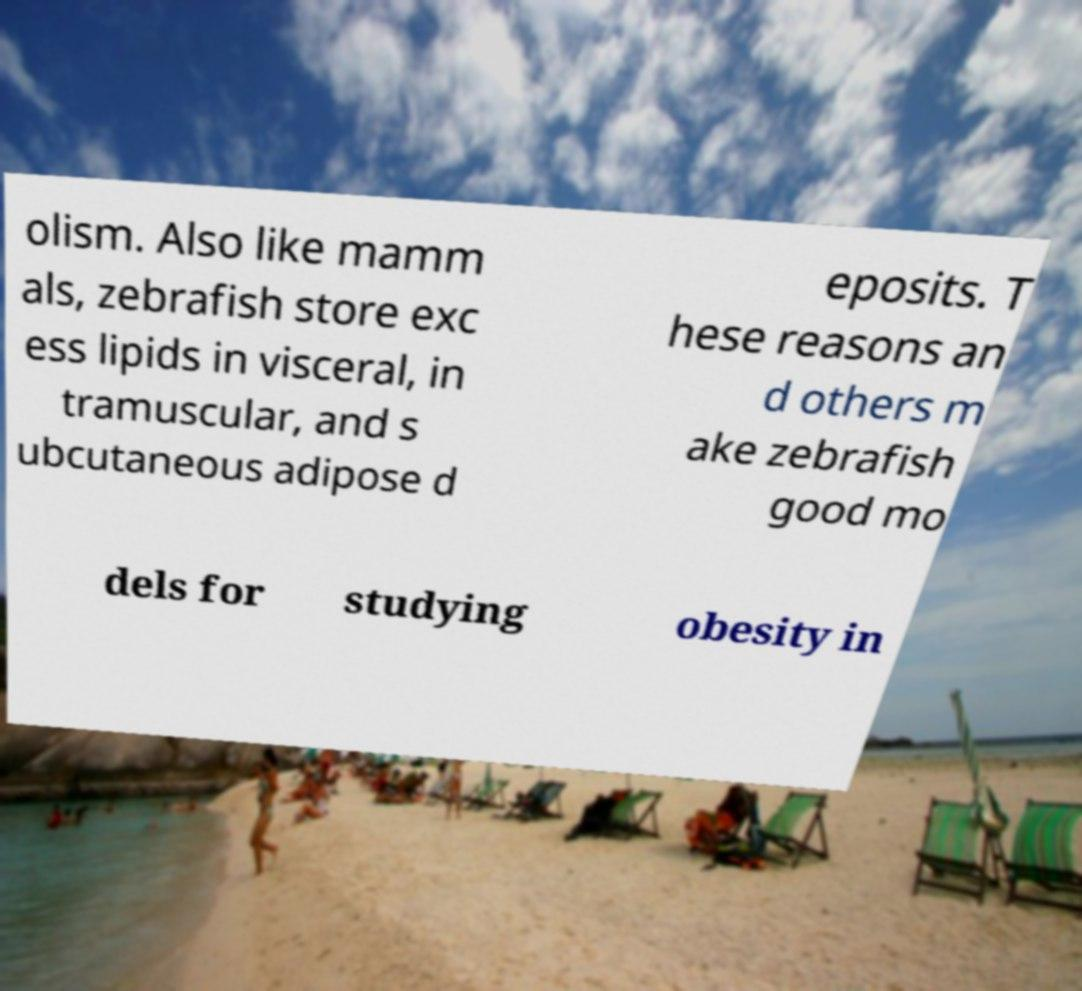Please read and relay the text visible in this image. What does it say? olism. Also like mamm als, zebrafish store exc ess lipids in visceral, in tramuscular, and s ubcutaneous adipose d eposits. T hese reasons an d others m ake zebrafish good mo dels for studying obesity in 